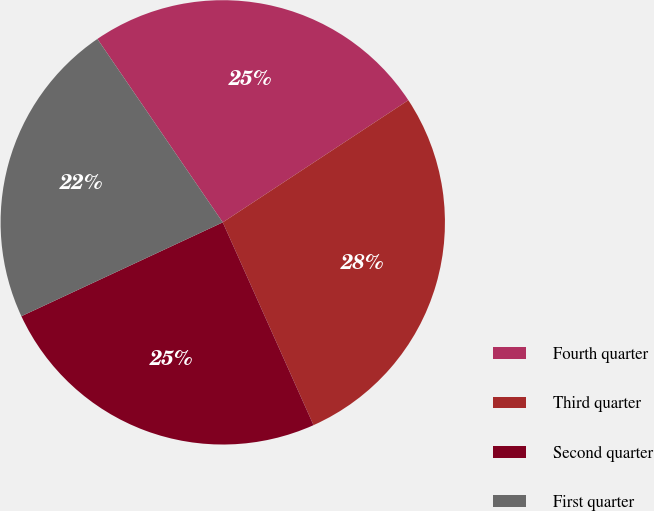<chart> <loc_0><loc_0><loc_500><loc_500><pie_chart><fcel>Fourth quarter<fcel>Third quarter<fcel>Second quarter<fcel>First quarter<nl><fcel>25.28%<fcel>27.57%<fcel>24.76%<fcel>22.4%<nl></chart> 